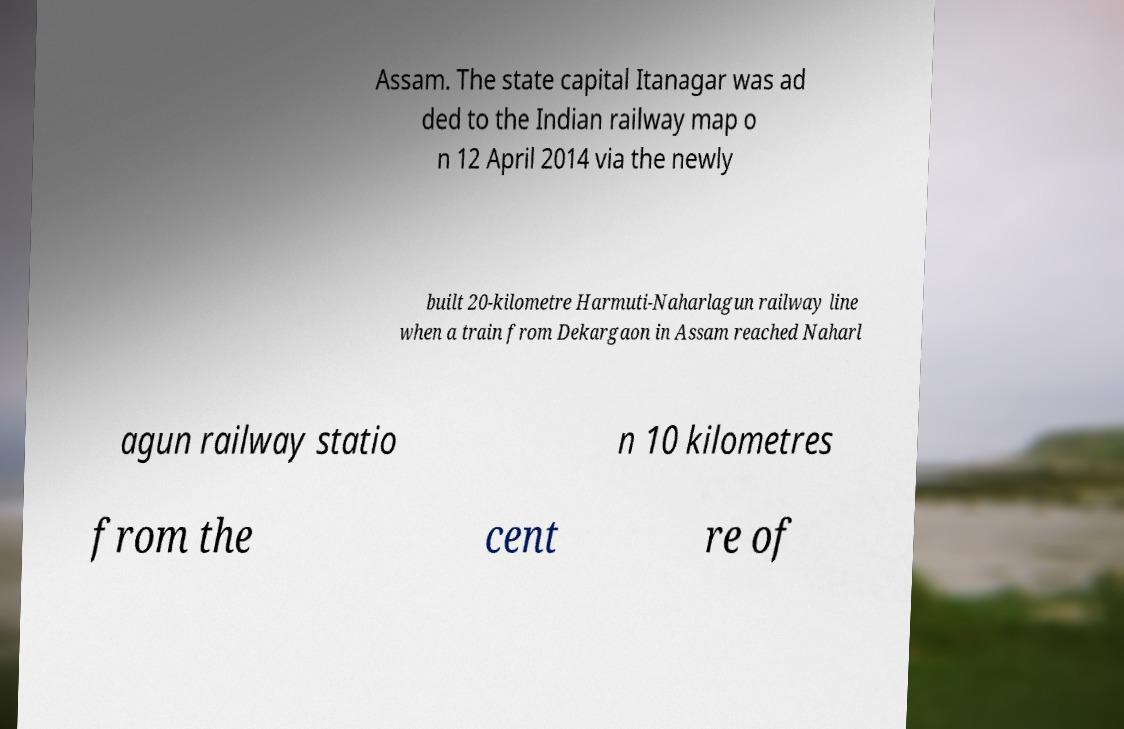Could you assist in decoding the text presented in this image and type it out clearly? Assam. The state capital Itanagar was ad ded to the Indian railway map o n 12 April 2014 via the newly built 20-kilometre Harmuti-Naharlagun railway line when a train from Dekargaon in Assam reached Naharl agun railway statio n 10 kilometres from the cent re of 